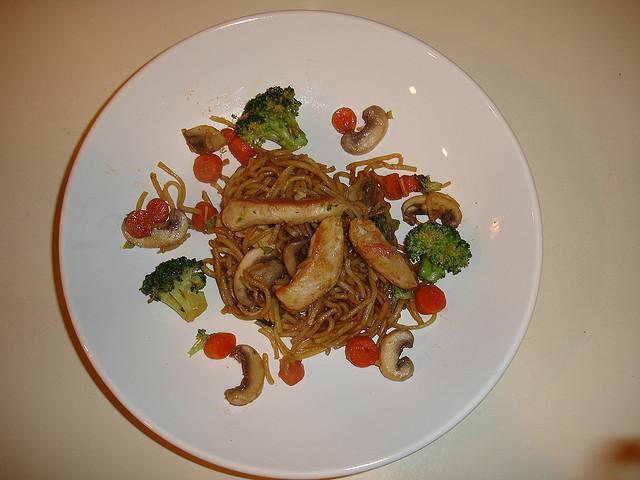How many tomatoes can you see?
Give a very brief answer. 0. How many broccolis are in the photo?
Give a very brief answer. 3. 